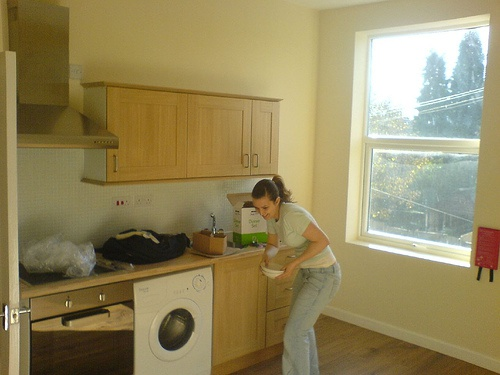Describe the objects in this image and their specific colors. I can see people in olive and gray tones, oven in olive and black tones, handbag in olive and black tones, backpack in olive and black tones, and bowl in olive and tan tones in this image. 